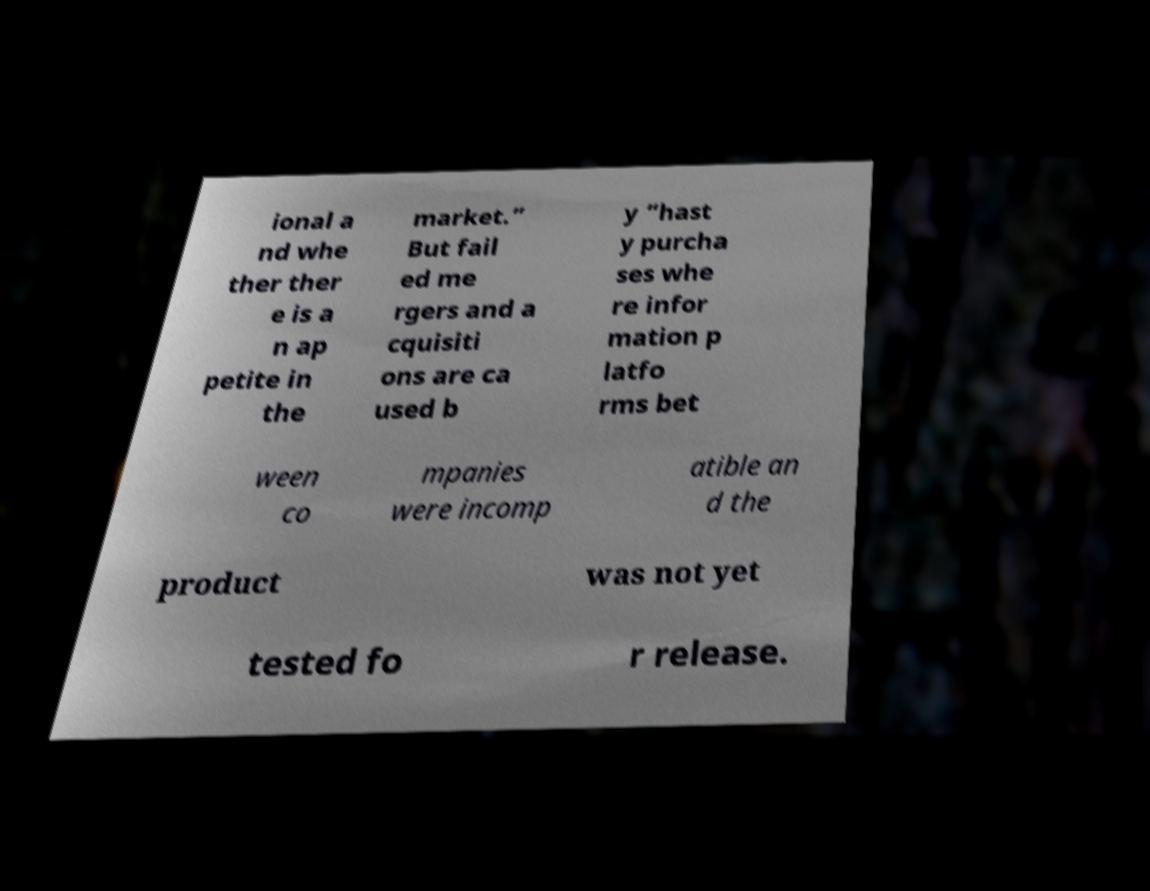There's text embedded in this image that I need extracted. Can you transcribe it verbatim? ional a nd whe ther ther e is a n ap petite in the market.” But fail ed me rgers and a cquisiti ons are ca used b y “hast y purcha ses whe re infor mation p latfo rms bet ween co mpanies were incomp atible an d the product was not yet tested fo r release. 